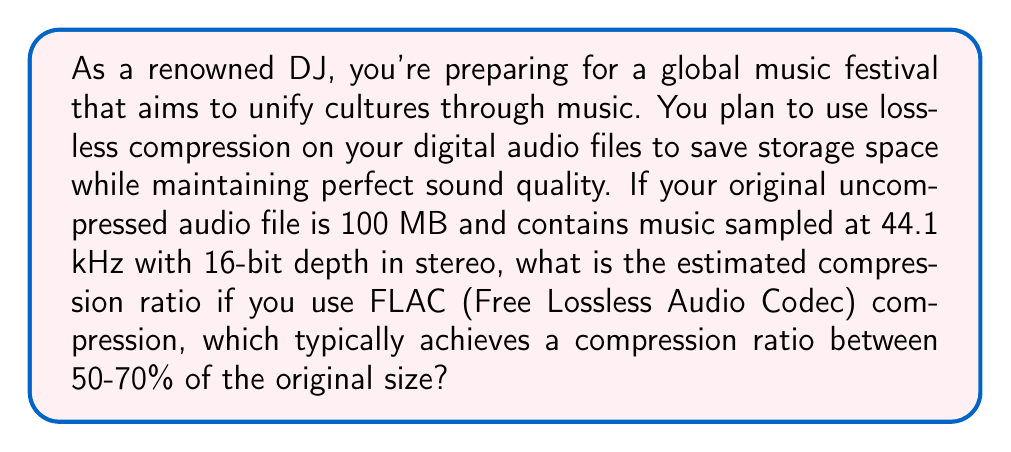Could you help me with this problem? To solve this problem, let's break it down into steps:

1. Understand the given information:
   - Original file size: 100 MB
   - Sampling rate: 44.1 kHz
   - Bit depth: 16-bit
   - Channels: Stereo (2 channels)
   - FLAC compression typically achieves 50-70% of the original size

2. Calculate the compression ratio range:
   - Lower bound: 50% of original size
   - Upper bound: 70% of original size

3. Calculate the compressed file size range:
   - Lower bound: $100 \text{ MB} \times 0.50 = 50 \text{ MB}$
   - Upper bound: $100 \text{ MB} \times 0.70 = 70 \text{ MB}$

4. Calculate the compression ratio:
   The compression ratio is defined as:
   $$ \text{Compression Ratio} = \frac{\text{Uncompressed Size}}{\text{Compressed Size}} $$

   For the lower bound (best compression):
   $$ \text{Compression Ratio}_{\text{lower}} = \frac{100 \text{ MB}}{50 \text{ MB}} = 2:1 $$

   For the upper bound (worst compression):
   $$ \text{Compression Ratio}_{\text{upper}} = \frac{100 \text{ MB}}{70 \text{ MB}} \approx 1.43:1 $$

5. Express the result as a range:
   The estimated compression ratio ranges from 1.43:1 to 2:1.
Answer: The estimated compression ratio for the FLAC-compressed audio file ranges from 1.43:1 to 2:1. 